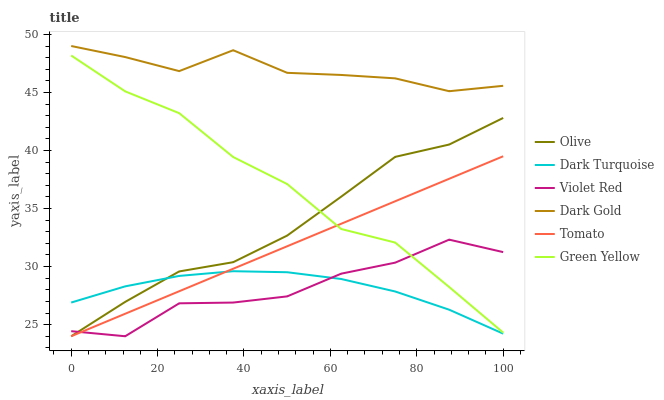Does Violet Red have the minimum area under the curve?
Answer yes or no. Yes. Does Dark Gold have the maximum area under the curve?
Answer yes or no. Yes. Does Dark Gold have the minimum area under the curve?
Answer yes or no. No. Does Violet Red have the maximum area under the curve?
Answer yes or no. No. Is Tomato the smoothest?
Answer yes or no. Yes. Is Violet Red the roughest?
Answer yes or no. Yes. Is Dark Gold the smoothest?
Answer yes or no. No. Is Dark Gold the roughest?
Answer yes or no. No. Does Tomato have the lowest value?
Answer yes or no. Yes. Does Dark Gold have the lowest value?
Answer yes or no. No. Does Dark Gold have the highest value?
Answer yes or no. Yes. Does Violet Red have the highest value?
Answer yes or no. No. Is Dark Turquoise less than Dark Gold?
Answer yes or no. Yes. Is Dark Gold greater than Green Yellow?
Answer yes or no. Yes. Does Dark Turquoise intersect Tomato?
Answer yes or no. Yes. Is Dark Turquoise less than Tomato?
Answer yes or no. No. Is Dark Turquoise greater than Tomato?
Answer yes or no. No. Does Dark Turquoise intersect Dark Gold?
Answer yes or no. No. 